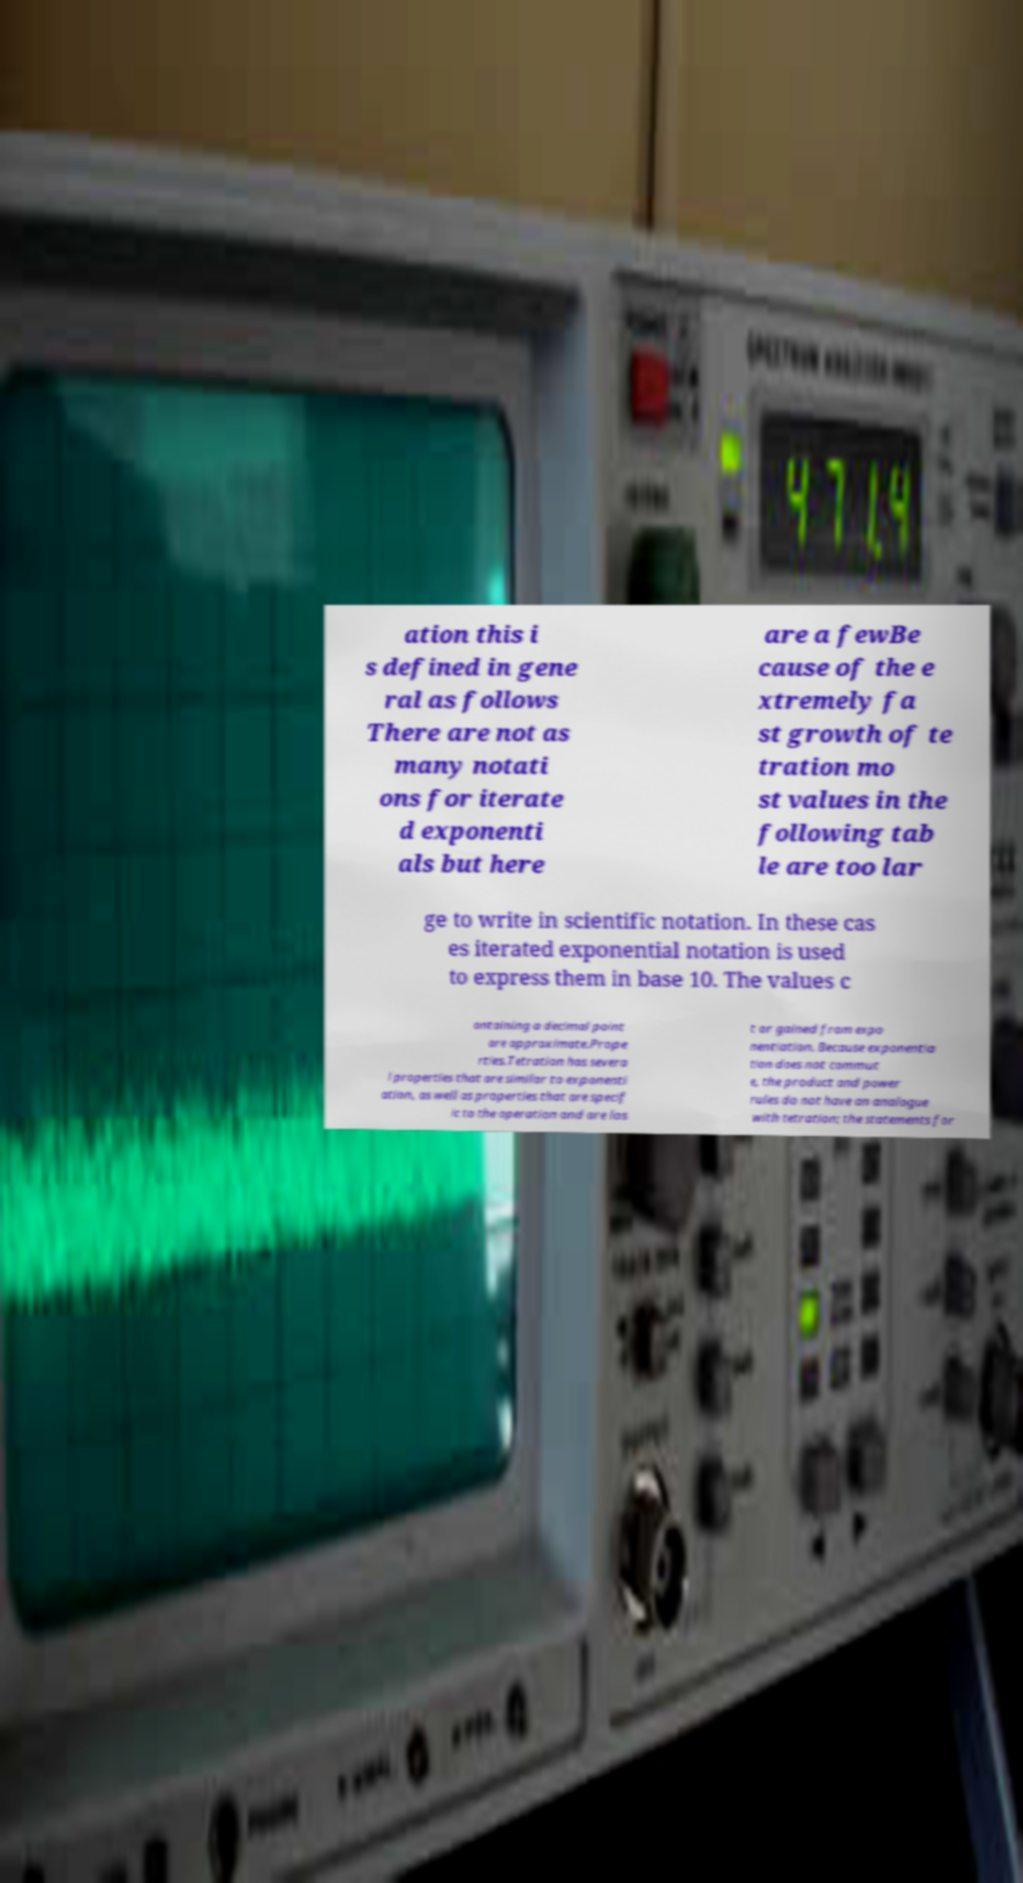Can you accurately transcribe the text from the provided image for me? ation this i s defined in gene ral as follows There are not as many notati ons for iterate d exponenti als but here are a fewBe cause of the e xtremely fa st growth of te tration mo st values in the following tab le are too lar ge to write in scientific notation. In these cas es iterated exponential notation is used to express them in base 10. The values c ontaining a decimal point are approximate.Prope rties.Tetration has severa l properties that are similar to exponenti ation, as well as properties that are specif ic to the operation and are los t or gained from expo nentiation. Because exponentia tion does not commut e, the product and power rules do not have an analogue with tetration; the statements for 